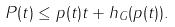Convert formula to latex. <formula><loc_0><loc_0><loc_500><loc_500>P ( t ) \leq p ( t ) t + h _ { G } ( p ( t ) ) .</formula> 